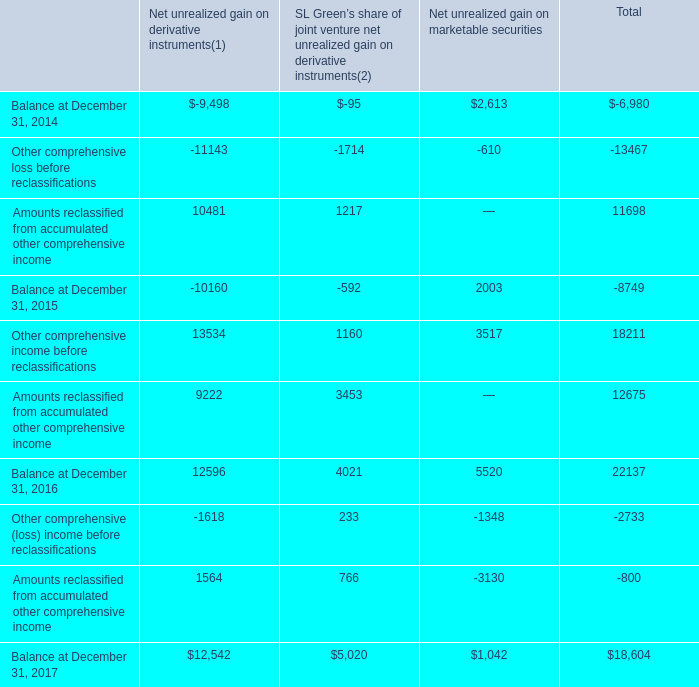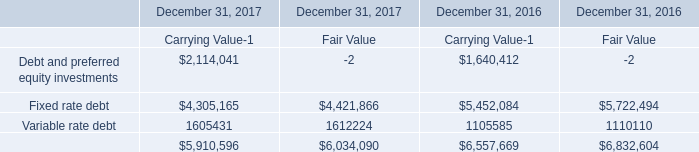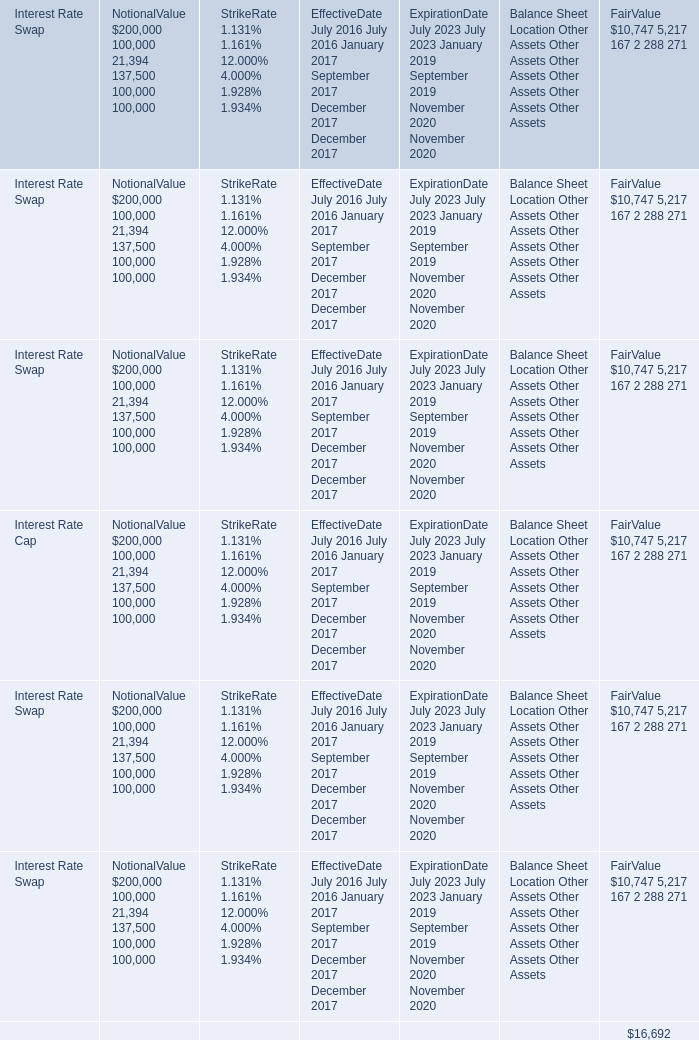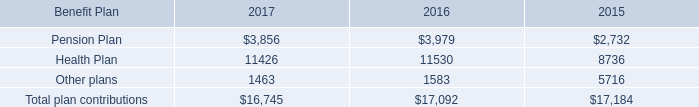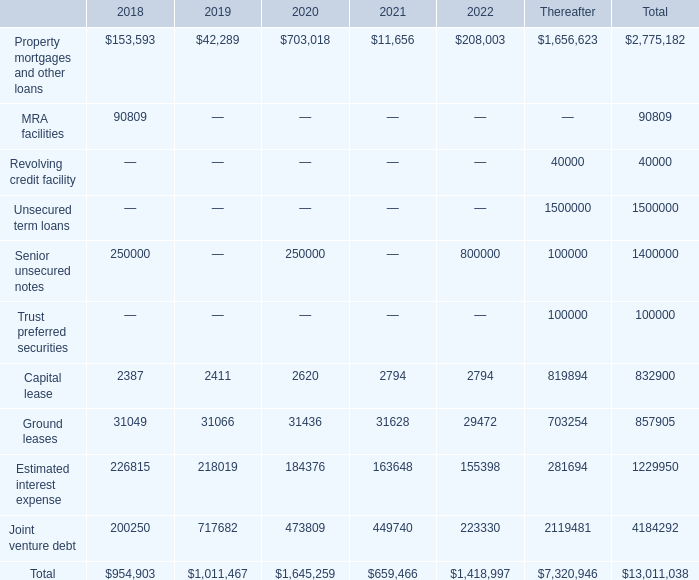what was the 2019 rate of increase in capital lease payments? 
Computations: ((2411 - 2387) / 2387)
Answer: 0.01005. 